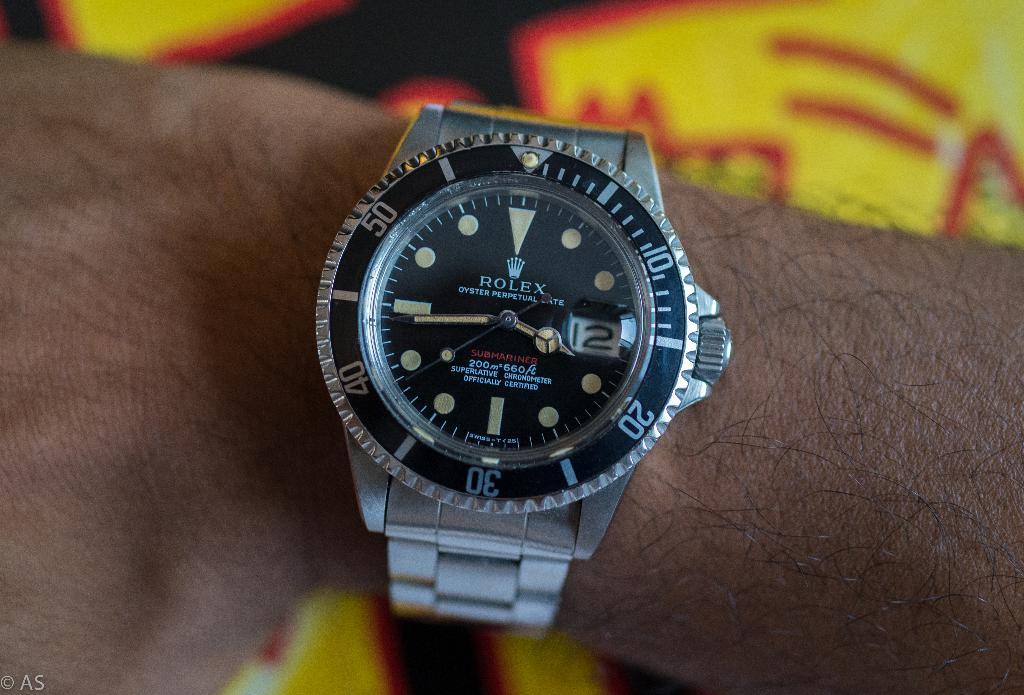What date is on the watch?
Provide a short and direct response. 12. What time is it?
Your answer should be compact. 3:44. 